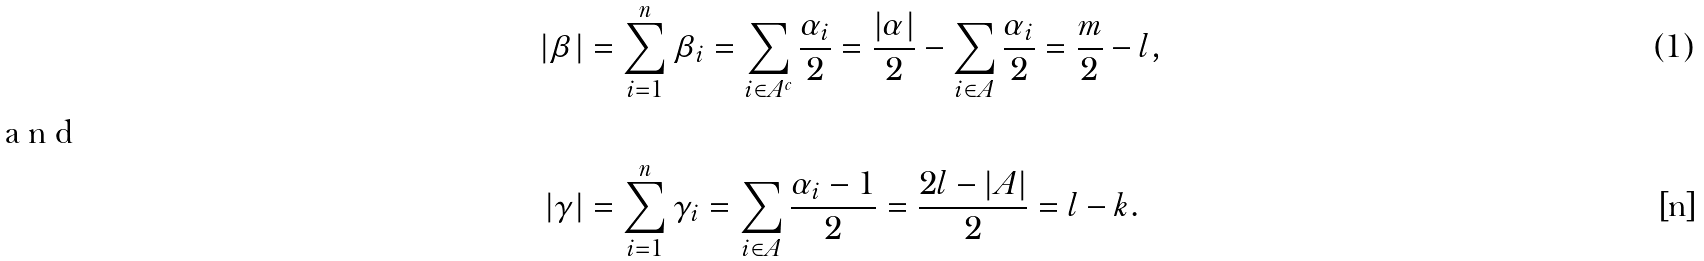Convert formula to latex. <formula><loc_0><loc_0><loc_500><loc_500>| \beta | & = \sum _ { i = 1 } ^ { n } \beta _ { i } = \sum _ { i \in A ^ { c } } \frac { \alpha _ { i } } { 2 } = \frac { | \alpha | } { 2 } - \sum _ { i \in A } \frac { \alpha _ { i } } { 2 } = \frac { m } { 2 } - l , \intertext { a n d } | \gamma | & = \sum _ { i = 1 } ^ { n } \gamma _ { i } = \sum _ { i \in A } \frac { \alpha _ { i } - 1 } { 2 } = \frac { 2 l - | A | } { 2 } = l - k .</formula> 